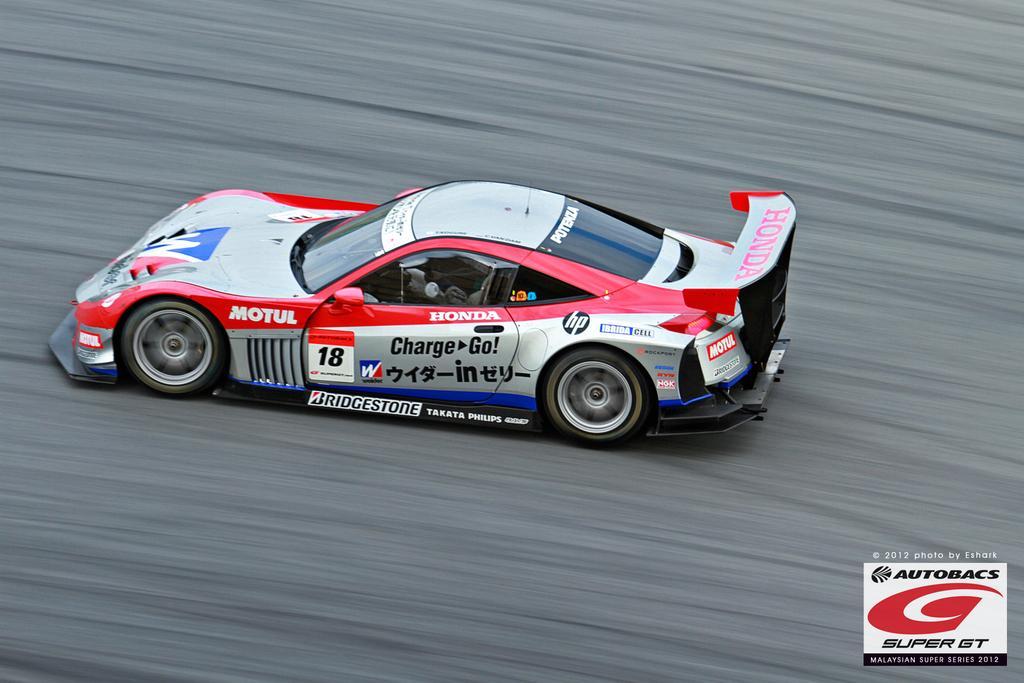How would you summarize this image in a sentence or two? In this image I can see a sports car on the road. On this car I can see logos. Here I can see a watermark. 